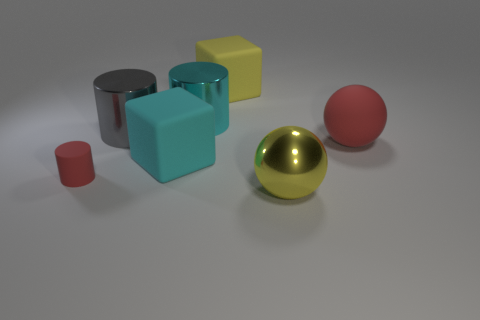Add 2 cyan rubber things. How many objects exist? 9 Subtract all spheres. How many objects are left? 5 Add 5 small purple cubes. How many small purple cubes exist? 5 Subtract 1 cyan cubes. How many objects are left? 6 Subtract all small gray matte balls. Subtract all yellow spheres. How many objects are left? 6 Add 3 big yellow matte blocks. How many big yellow matte blocks are left? 4 